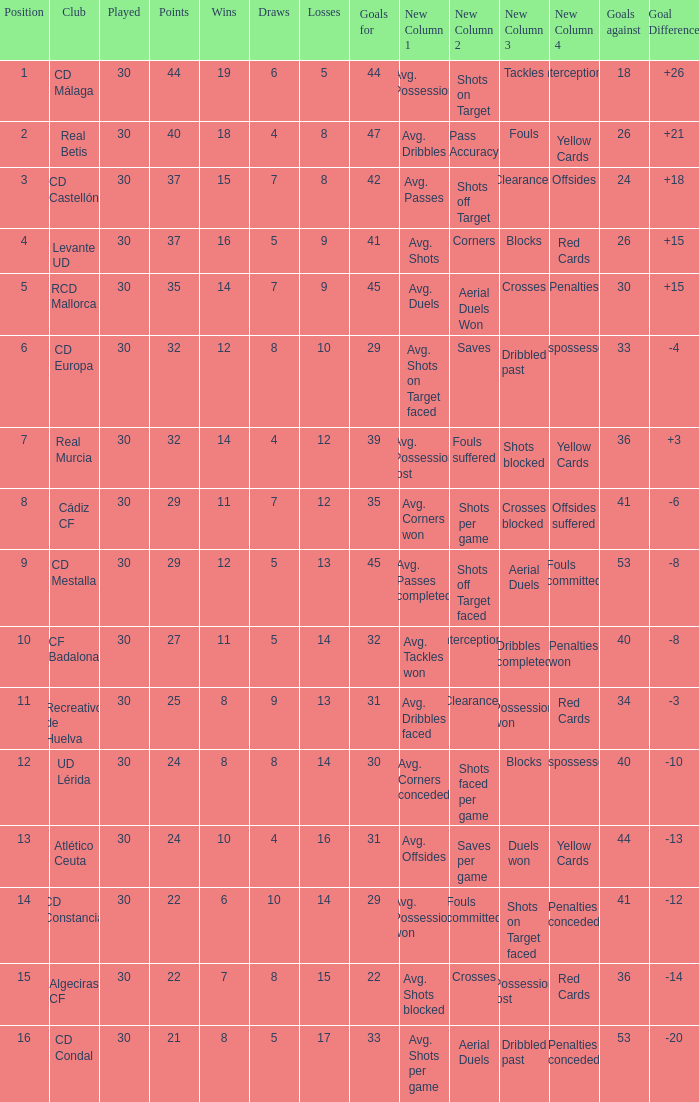What is the number of wins when the goals against is larger than 41, points is 29, and draws are larger than 5? 0.0. Could you help me parse every detail presented in this table? {'header': ['Position', 'Club', 'Played', 'Points', 'Wins', 'Draws', 'Losses', 'Goals for', 'New Column 1', 'New Column 2', 'New Column 3', 'New Column 4', 'Goals against', 'Goal Difference'], 'rows': [['1', 'CD Málaga', '30', '44', '19', '6', '5', '44', 'Avg. Possession', 'Shots on Target', 'Tackles', 'Interceptions', '18', '+26'], ['2', 'Real Betis', '30', '40', '18', '4', '8', '47', 'Avg. Dribbles', 'Pass Accuracy', 'Fouls', 'Yellow Cards', '26', '+21'], ['3', 'CD Castellón', '30', '37', '15', '7', '8', '42', 'Avg. Passes', 'Shots off Target', 'Clearances', 'Offsides', '24', '+18'], ['4', 'Levante UD', '30', '37', '16', '5', '9', '41', 'Avg. Shots', 'Corners', 'Blocks', 'Red Cards', '26', '+15'], ['5', 'RCD Mallorca', '30', '35', '14', '7', '9', '45', 'Avg. Duels', 'Aerial Duels Won', 'Crosses', 'Penalties', '30', '+15'], ['6', 'CD Europa', '30', '32', '12', '8', '10', '29', 'Avg. Shots on Target faced', 'Saves', 'Dribbled past', 'Dispossessed', '33', '-4'], ['7', 'Real Murcia', '30', '32', '14', '4', '12', '39', 'Avg. Possession lost', 'Fouls suffered', 'Shots blocked', 'Yellow Cards', '36', '+3'], ['8', 'Cádiz CF', '30', '29', '11', '7', '12', '35', 'Avg. Corners won', 'Shots per game', 'Crosses blocked', 'Offsides suffered', '41', '-6'], ['9', 'CD Mestalla', '30', '29', '12', '5', '13', '45', 'Avg. Passes completed', 'Shots off Target faced', 'Aerial Duels', 'Fouls committed', '53', '-8'], ['10', 'CF Badalona', '30', '27', '11', '5', '14', '32', 'Avg. Tackles won', 'Interceptions', 'Dribbles completed', 'Penalties won', '40', '-8'], ['11', 'Recreativo de Huelva', '30', '25', '8', '9', '13', '31', 'Avg. Dribbles faced', 'Clearances', 'Possession won', 'Red Cards', '34', '-3'], ['12', 'UD Lérida', '30', '24', '8', '8', '14', '30', 'Avg. Corners conceded', 'Shots faced per game', 'Blocks', 'Dispossessed', '40', '-10'], ['13', 'Atlético Ceuta', '30', '24', '10', '4', '16', '31', 'Avg. Offsides', 'Saves per game', 'Duels won', 'Yellow Cards', '44', '-13'], ['14', 'CD Constancia', '30', '22', '6', '10', '14', '29', 'Avg. Possession won', 'Fouls committed', 'Shots on Target faced', 'Penalties conceded', '41', '-12'], ['15', 'Algeciras CF', '30', '22', '7', '8', '15', '22', 'Avg. Shots blocked', 'Crosses', 'Possession lost', 'Red Cards', '36', '-14'], ['16', 'CD Condal', '30', '21', '8', '5', '17', '33', 'Avg. Shots per game', 'Aerial Duels', 'Dribbled past', 'Penalties conceded', '53', '-20']]} 